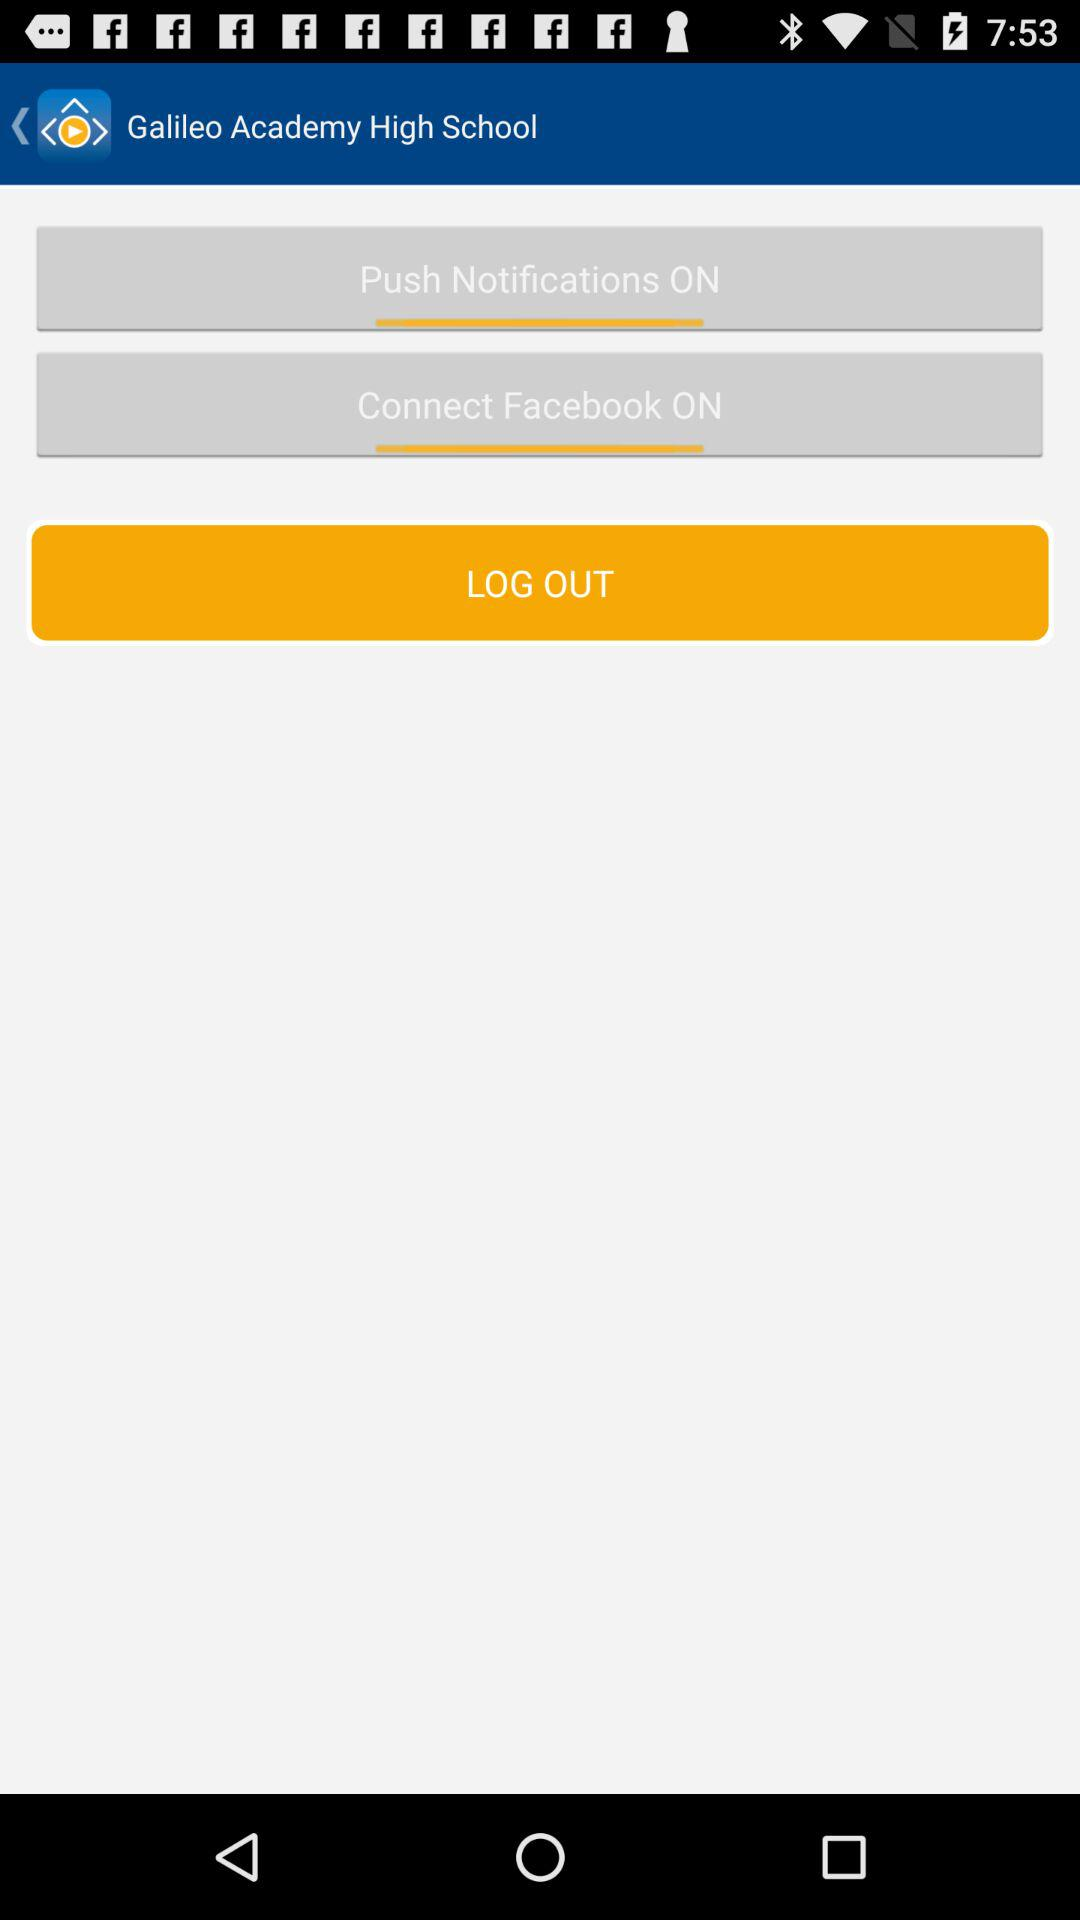What is the status of push notifications? The status is on. 